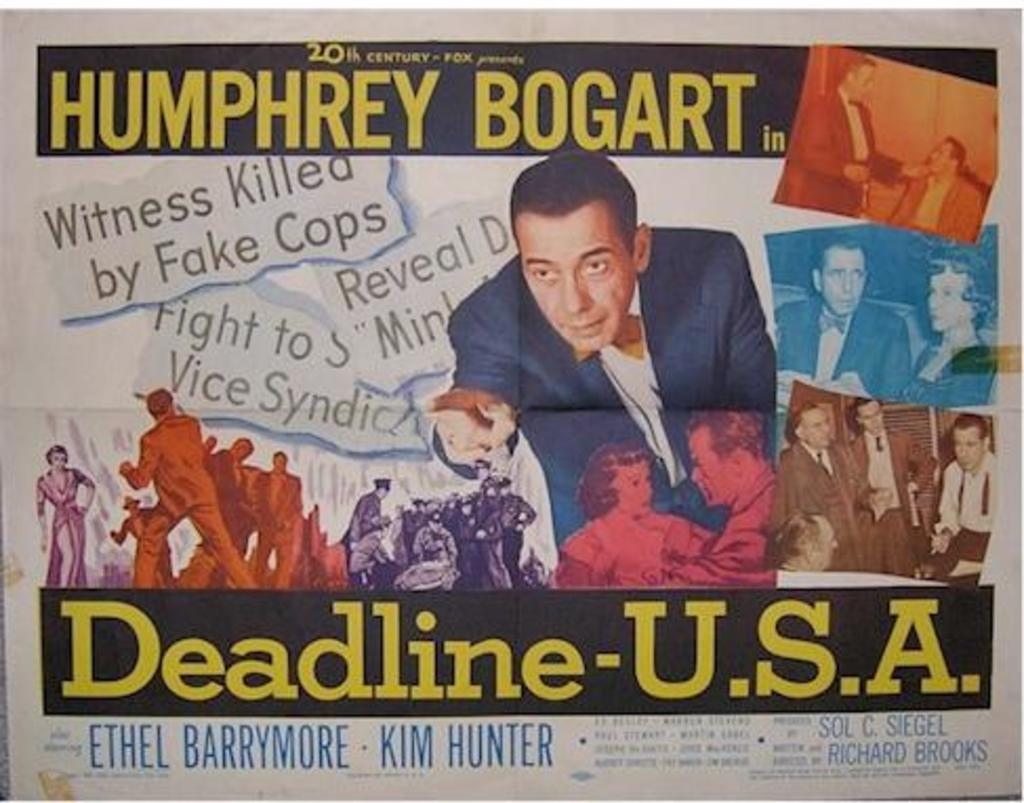<image>
Provide a brief description of the given image. A movie poster for Deadline USA starring Humphrey Bogart. 